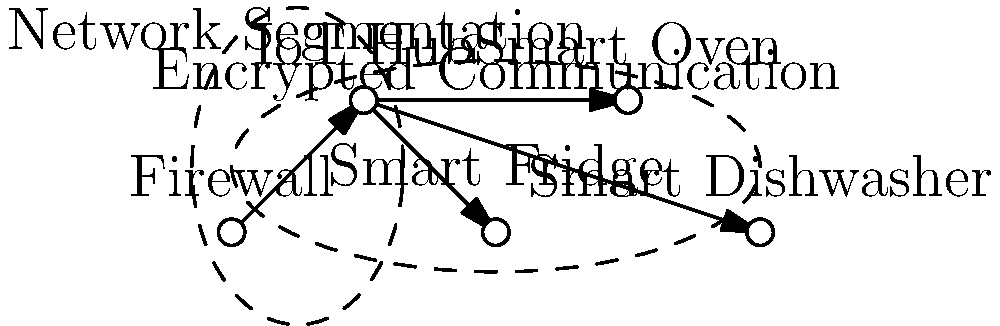In the network security schematic for high-end IoT kitchen devices, which component serves as the central point for device communication and acts as a security intermediary between the devices and the external network? To answer this question, let's analyze the components of the network security schematic:

1. Firewall: This is the first line of defense, protecting the internal network from external threats. It filters incoming and outgoing traffic based on predetermined security rules.

2. IoT Hub: This component is positioned centrally in the diagram, connecting to all the smart kitchen devices (Smart Fridge, Smart Oven, and Smart Dishwasher). It acts as a central communication point for all IoT devices.

3. Smart Devices: These are the end devices (Smart Fridge, Smart Oven, and Smart Dishwasher) that need to be protected and managed.

4. Encrypted Communication: This layer encompasses all the smart devices and the IoT Hub, indicating that all communication between these components is encrypted.

5. Network Segmentation: This layer separates the IoT devices from the main network, adding an extra layer of security.

The IoT Hub serves as the central point for device communication because:

a) It's directly connected to all smart devices.
b) It's positioned between the Firewall (external network) and the smart devices (internal network).
c) It's included in the encrypted communication layer, ensuring secure data transmission.

Therefore, the IoT Hub acts as both a central communication point and a security intermediary between the devices and the external network.
Answer: IoT Hub 